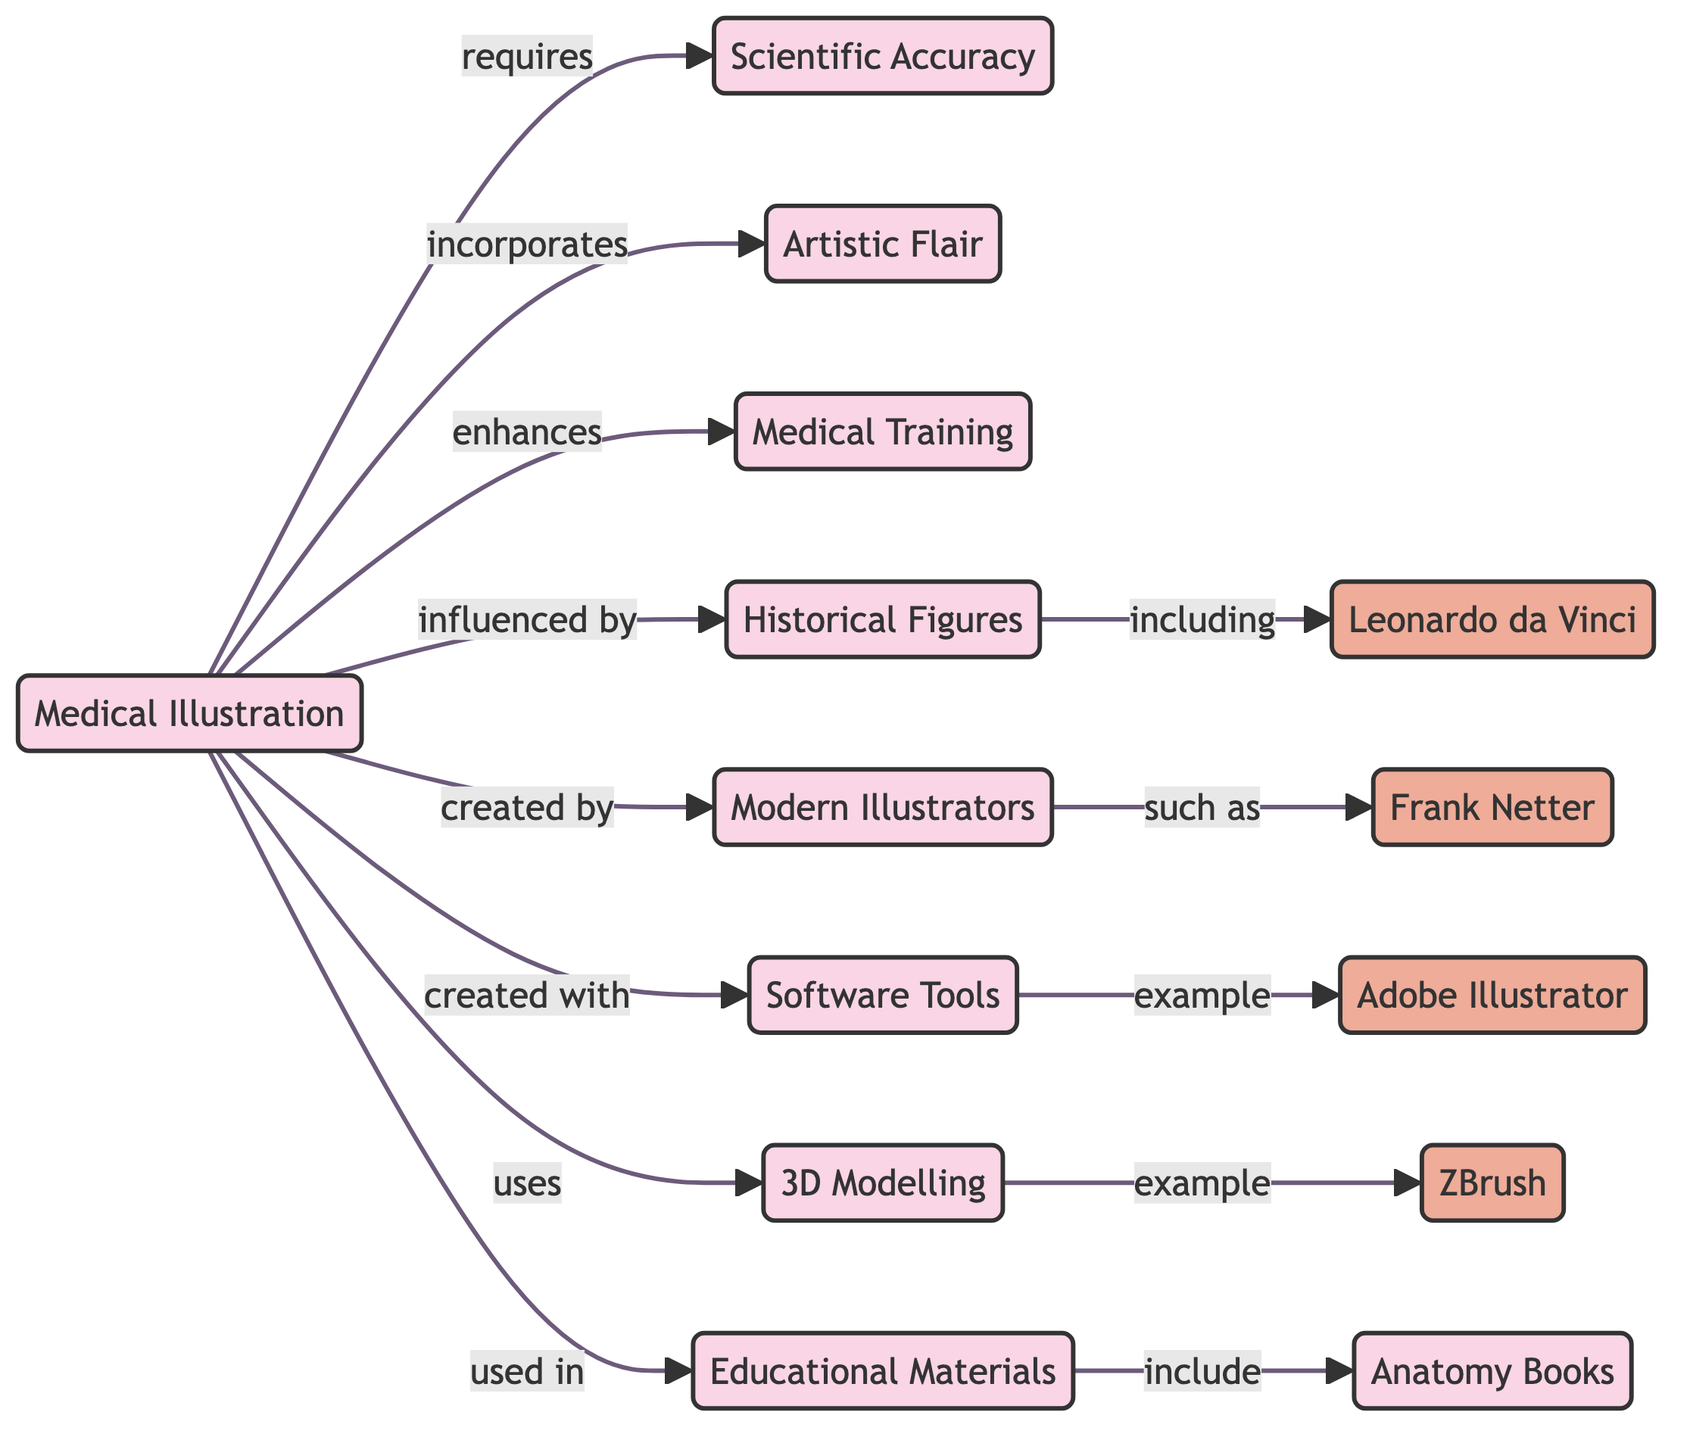What concept is required for Medical Illustration? The diagram shows that Medical Illustration requires Scientific Accuracy as indicated by the arrow and relationship label "requires".
Answer: Scientific Accuracy What is incorporated into Medical Illustration? The diagram clearly indicates that Medical Illustration incorporates Artistic Flair, as shown by the relationship labeled "incorporates".
Answer: Artistic Flair How many modern illustrators are specifically mentioned in the diagram? The diagram lists one modern illustrator, Frank Netter, connected to the node Modern Illustrators by the relationship labeled "such as".
Answer: One Who is an example of a historical figure in Medical Illustration? The diagram specifies that Leonardo da Vinci is an example of a historical figure, indicated by the connection from Historical Figures to Leonardo da Vinci with "including".
Answer: Leonardo da Vinci What tools are used in creating Medical Illustration? The connections from Medical Illustration to Software Tools and 3D Modelling indicate that various software and 3D modeling tools are involved. The specific tools listed include Adobe Illustrator and ZBrush.
Answer: Software Tools Which educational materials are included in the context of Medical Training? The diagram connects Educational Materials to Anatomy Books with the label "include", indicating that Anatomy Books are a type of educational material relevant to the training.
Answer: Anatomy Books How does Medical Illustration enhance Medical Training? The diagram signifies that Medical Illustration enhances Medical Training with the relationship labeled "enhances", revealing its importance in the educational process for medical professionals.
Answer: Enhances What tool is mentioned as an example of Software Tools? The diagram explicitly cites Adobe Illustrator under the node Software Tools, with the label "example" demonstrating it's a representative tool in this category.
Answer: Adobe Illustrator What type of modelling is used in Medical Illustration? The diagram identifies that Medical Illustration uses 3D Modelling, as indicated by the relationship labeled "uses", highlighting its relevance in creating three-dimensional representations.
Answer: 3D Modelling 